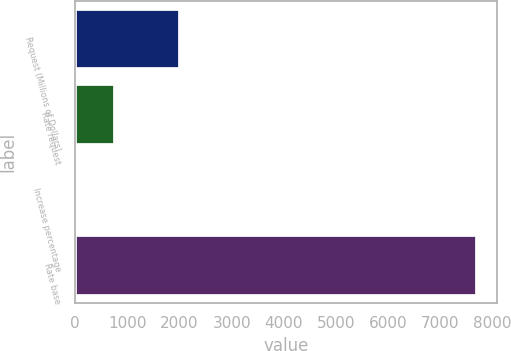Convert chart to OTSL. <chart><loc_0><loc_0><loc_500><loc_500><bar_chart><fcel>Request (Millions of Dollars)<fcel>Rate request<fcel>Increase percentage<fcel>Rate base<nl><fcel>2018<fcel>771.53<fcel>1.7<fcel>7700<nl></chart> 